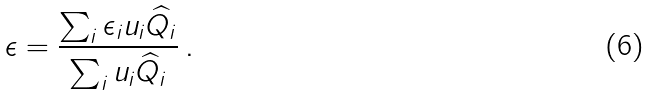<formula> <loc_0><loc_0><loc_500><loc_500>\epsilon = \frac { \sum _ { i } \epsilon _ { i } u _ { i } \widehat { Q } _ { i } } { \sum _ { i } u _ { i } \widehat { Q } _ { i } } \, .</formula> 